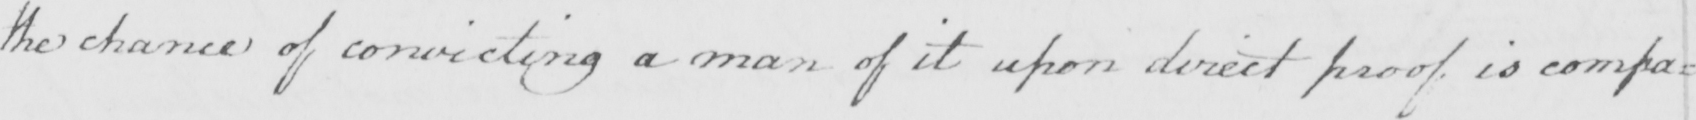Can you tell me what this handwritten text says? the chance of convicting a man of it upon direct proof is compa= 